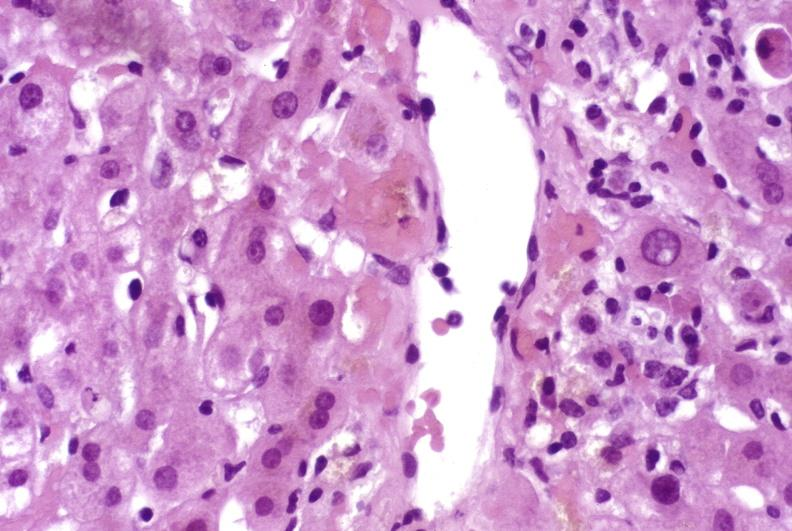s hepatobiliary present?
Answer the question using a single word or phrase. Yes 